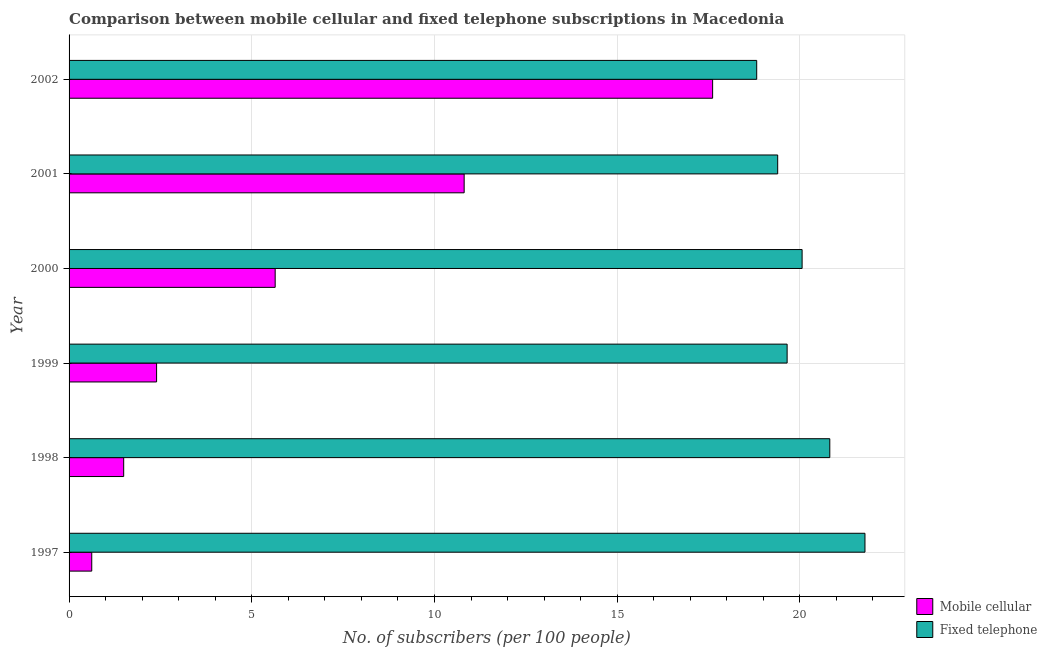How many different coloured bars are there?
Your answer should be very brief. 2. How many groups of bars are there?
Offer a terse response. 6. How many bars are there on the 1st tick from the top?
Offer a terse response. 2. How many bars are there on the 2nd tick from the bottom?
Offer a very short reply. 2. What is the label of the 3rd group of bars from the top?
Offer a very short reply. 2000. In how many cases, is the number of bars for a given year not equal to the number of legend labels?
Give a very brief answer. 0. What is the number of fixed telephone subscribers in 2001?
Make the answer very short. 19.39. Across all years, what is the maximum number of fixed telephone subscribers?
Provide a short and direct response. 21.78. Across all years, what is the minimum number of mobile cellular subscribers?
Provide a succinct answer. 0.62. In which year was the number of fixed telephone subscribers maximum?
Ensure brevity in your answer.  1997. In which year was the number of mobile cellular subscribers minimum?
Give a very brief answer. 1997. What is the total number of mobile cellular subscribers in the graph?
Your response must be concise. 38.57. What is the difference between the number of mobile cellular subscribers in 2000 and that in 2001?
Your answer should be very brief. -5.17. What is the difference between the number of fixed telephone subscribers in 1997 and the number of mobile cellular subscribers in 2000?
Ensure brevity in your answer.  16.14. What is the average number of fixed telephone subscribers per year?
Provide a short and direct response. 20.09. In the year 2001, what is the difference between the number of fixed telephone subscribers and number of mobile cellular subscribers?
Offer a terse response. 8.58. What is the ratio of the number of mobile cellular subscribers in 1997 to that in 1999?
Give a very brief answer. 0.26. Is the number of fixed telephone subscribers in 1997 less than that in 1999?
Give a very brief answer. No. Is the difference between the number of fixed telephone subscribers in 2001 and 2002 greater than the difference between the number of mobile cellular subscribers in 2001 and 2002?
Make the answer very short. Yes. What is the difference between the highest and the second highest number of mobile cellular subscribers?
Your response must be concise. 6.8. What is the difference between the highest and the lowest number of mobile cellular subscribers?
Your response must be concise. 16.99. Is the sum of the number of mobile cellular subscribers in 1997 and 2002 greater than the maximum number of fixed telephone subscribers across all years?
Provide a succinct answer. No. What does the 2nd bar from the top in 1997 represents?
Your response must be concise. Mobile cellular. What does the 2nd bar from the bottom in 2001 represents?
Keep it short and to the point. Fixed telephone. How many bars are there?
Your answer should be very brief. 12. Are all the bars in the graph horizontal?
Ensure brevity in your answer.  Yes. What is the difference between two consecutive major ticks on the X-axis?
Your answer should be very brief. 5. Are the values on the major ticks of X-axis written in scientific E-notation?
Your answer should be compact. No. Does the graph contain any zero values?
Your answer should be compact. No. How many legend labels are there?
Ensure brevity in your answer.  2. How are the legend labels stacked?
Your answer should be very brief. Vertical. What is the title of the graph?
Ensure brevity in your answer.  Comparison between mobile cellular and fixed telephone subscriptions in Macedonia. Does "constant 2005 US$" appear as one of the legend labels in the graph?
Provide a succinct answer. No. What is the label or title of the X-axis?
Your answer should be compact. No. of subscribers (per 100 people). What is the label or title of the Y-axis?
Ensure brevity in your answer.  Year. What is the No. of subscribers (per 100 people) of Mobile cellular in 1997?
Your answer should be very brief. 0.62. What is the No. of subscribers (per 100 people) in Fixed telephone in 1997?
Your response must be concise. 21.78. What is the No. of subscribers (per 100 people) of Mobile cellular in 1998?
Your answer should be compact. 1.49. What is the No. of subscribers (per 100 people) in Fixed telephone in 1998?
Make the answer very short. 20.82. What is the No. of subscribers (per 100 people) of Mobile cellular in 1999?
Your answer should be compact. 2.4. What is the No. of subscribers (per 100 people) in Fixed telephone in 1999?
Your response must be concise. 19.65. What is the No. of subscribers (per 100 people) in Mobile cellular in 2000?
Offer a terse response. 5.64. What is the No. of subscribers (per 100 people) in Fixed telephone in 2000?
Make the answer very short. 20.06. What is the No. of subscribers (per 100 people) in Mobile cellular in 2001?
Offer a very short reply. 10.81. What is the No. of subscribers (per 100 people) of Fixed telephone in 2001?
Keep it short and to the point. 19.39. What is the No. of subscribers (per 100 people) in Mobile cellular in 2002?
Provide a succinct answer. 17.61. What is the No. of subscribers (per 100 people) of Fixed telephone in 2002?
Your response must be concise. 18.82. Across all years, what is the maximum No. of subscribers (per 100 people) of Mobile cellular?
Offer a terse response. 17.61. Across all years, what is the maximum No. of subscribers (per 100 people) of Fixed telephone?
Your answer should be compact. 21.78. Across all years, what is the minimum No. of subscribers (per 100 people) of Mobile cellular?
Keep it short and to the point. 0.62. Across all years, what is the minimum No. of subscribers (per 100 people) in Fixed telephone?
Make the answer very short. 18.82. What is the total No. of subscribers (per 100 people) of Mobile cellular in the graph?
Provide a succinct answer. 38.57. What is the total No. of subscribers (per 100 people) of Fixed telephone in the graph?
Offer a very short reply. 120.52. What is the difference between the No. of subscribers (per 100 people) of Mobile cellular in 1997 and that in 1998?
Offer a terse response. -0.87. What is the difference between the No. of subscribers (per 100 people) in Fixed telephone in 1997 and that in 1998?
Provide a short and direct response. 0.96. What is the difference between the No. of subscribers (per 100 people) of Mobile cellular in 1997 and that in 1999?
Give a very brief answer. -1.77. What is the difference between the No. of subscribers (per 100 people) in Fixed telephone in 1997 and that in 1999?
Your answer should be compact. 2.13. What is the difference between the No. of subscribers (per 100 people) of Mobile cellular in 1997 and that in 2000?
Provide a succinct answer. -5.02. What is the difference between the No. of subscribers (per 100 people) in Fixed telephone in 1997 and that in 2000?
Keep it short and to the point. 1.72. What is the difference between the No. of subscribers (per 100 people) in Mobile cellular in 1997 and that in 2001?
Keep it short and to the point. -10.19. What is the difference between the No. of subscribers (per 100 people) of Fixed telephone in 1997 and that in 2001?
Give a very brief answer. 2.39. What is the difference between the No. of subscribers (per 100 people) of Mobile cellular in 1997 and that in 2002?
Your answer should be compact. -16.99. What is the difference between the No. of subscribers (per 100 people) of Fixed telephone in 1997 and that in 2002?
Your answer should be compact. 2.96. What is the difference between the No. of subscribers (per 100 people) of Mobile cellular in 1998 and that in 1999?
Offer a terse response. -0.9. What is the difference between the No. of subscribers (per 100 people) of Fixed telephone in 1998 and that in 1999?
Make the answer very short. 1.17. What is the difference between the No. of subscribers (per 100 people) in Mobile cellular in 1998 and that in 2000?
Provide a short and direct response. -4.15. What is the difference between the No. of subscribers (per 100 people) in Fixed telephone in 1998 and that in 2000?
Ensure brevity in your answer.  0.76. What is the difference between the No. of subscribers (per 100 people) of Mobile cellular in 1998 and that in 2001?
Offer a terse response. -9.32. What is the difference between the No. of subscribers (per 100 people) in Fixed telephone in 1998 and that in 2001?
Provide a succinct answer. 1.43. What is the difference between the No. of subscribers (per 100 people) in Mobile cellular in 1998 and that in 2002?
Your response must be concise. -16.12. What is the difference between the No. of subscribers (per 100 people) of Fixed telephone in 1998 and that in 2002?
Your answer should be compact. 2. What is the difference between the No. of subscribers (per 100 people) in Mobile cellular in 1999 and that in 2000?
Provide a succinct answer. -3.25. What is the difference between the No. of subscribers (per 100 people) in Fixed telephone in 1999 and that in 2000?
Ensure brevity in your answer.  -0.41. What is the difference between the No. of subscribers (per 100 people) of Mobile cellular in 1999 and that in 2001?
Give a very brief answer. -8.42. What is the difference between the No. of subscribers (per 100 people) of Fixed telephone in 1999 and that in 2001?
Your response must be concise. 0.26. What is the difference between the No. of subscribers (per 100 people) of Mobile cellular in 1999 and that in 2002?
Your answer should be compact. -15.22. What is the difference between the No. of subscribers (per 100 people) in Fixed telephone in 1999 and that in 2002?
Your answer should be very brief. 0.83. What is the difference between the No. of subscribers (per 100 people) of Mobile cellular in 2000 and that in 2001?
Offer a terse response. -5.17. What is the difference between the No. of subscribers (per 100 people) of Fixed telephone in 2000 and that in 2001?
Make the answer very short. 0.67. What is the difference between the No. of subscribers (per 100 people) in Mobile cellular in 2000 and that in 2002?
Ensure brevity in your answer.  -11.97. What is the difference between the No. of subscribers (per 100 people) in Fixed telephone in 2000 and that in 2002?
Provide a short and direct response. 1.24. What is the difference between the No. of subscribers (per 100 people) in Mobile cellular in 2001 and that in 2002?
Your answer should be compact. -6.8. What is the difference between the No. of subscribers (per 100 people) of Fixed telephone in 2001 and that in 2002?
Offer a terse response. 0.57. What is the difference between the No. of subscribers (per 100 people) of Mobile cellular in 1997 and the No. of subscribers (per 100 people) of Fixed telephone in 1998?
Ensure brevity in your answer.  -20.2. What is the difference between the No. of subscribers (per 100 people) in Mobile cellular in 1997 and the No. of subscribers (per 100 people) in Fixed telephone in 1999?
Ensure brevity in your answer.  -19.03. What is the difference between the No. of subscribers (per 100 people) of Mobile cellular in 1997 and the No. of subscribers (per 100 people) of Fixed telephone in 2000?
Keep it short and to the point. -19.44. What is the difference between the No. of subscribers (per 100 people) in Mobile cellular in 1997 and the No. of subscribers (per 100 people) in Fixed telephone in 2001?
Give a very brief answer. -18.77. What is the difference between the No. of subscribers (per 100 people) of Mobile cellular in 1997 and the No. of subscribers (per 100 people) of Fixed telephone in 2002?
Make the answer very short. -18.2. What is the difference between the No. of subscribers (per 100 people) in Mobile cellular in 1998 and the No. of subscribers (per 100 people) in Fixed telephone in 1999?
Ensure brevity in your answer.  -18.16. What is the difference between the No. of subscribers (per 100 people) of Mobile cellular in 1998 and the No. of subscribers (per 100 people) of Fixed telephone in 2000?
Keep it short and to the point. -18.57. What is the difference between the No. of subscribers (per 100 people) in Mobile cellular in 1998 and the No. of subscribers (per 100 people) in Fixed telephone in 2001?
Your answer should be compact. -17.9. What is the difference between the No. of subscribers (per 100 people) of Mobile cellular in 1998 and the No. of subscribers (per 100 people) of Fixed telephone in 2002?
Your answer should be compact. -17.32. What is the difference between the No. of subscribers (per 100 people) in Mobile cellular in 1999 and the No. of subscribers (per 100 people) in Fixed telephone in 2000?
Provide a short and direct response. -17.67. What is the difference between the No. of subscribers (per 100 people) in Mobile cellular in 1999 and the No. of subscribers (per 100 people) in Fixed telephone in 2001?
Your response must be concise. -17. What is the difference between the No. of subscribers (per 100 people) of Mobile cellular in 1999 and the No. of subscribers (per 100 people) of Fixed telephone in 2002?
Ensure brevity in your answer.  -16.42. What is the difference between the No. of subscribers (per 100 people) in Mobile cellular in 2000 and the No. of subscribers (per 100 people) in Fixed telephone in 2001?
Your answer should be compact. -13.75. What is the difference between the No. of subscribers (per 100 people) of Mobile cellular in 2000 and the No. of subscribers (per 100 people) of Fixed telephone in 2002?
Make the answer very short. -13.18. What is the difference between the No. of subscribers (per 100 people) of Mobile cellular in 2001 and the No. of subscribers (per 100 people) of Fixed telephone in 2002?
Offer a very short reply. -8.01. What is the average No. of subscribers (per 100 people) of Mobile cellular per year?
Provide a short and direct response. 6.43. What is the average No. of subscribers (per 100 people) of Fixed telephone per year?
Make the answer very short. 20.09. In the year 1997, what is the difference between the No. of subscribers (per 100 people) of Mobile cellular and No. of subscribers (per 100 people) of Fixed telephone?
Offer a very short reply. -21.16. In the year 1998, what is the difference between the No. of subscribers (per 100 people) of Mobile cellular and No. of subscribers (per 100 people) of Fixed telephone?
Ensure brevity in your answer.  -19.32. In the year 1999, what is the difference between the No. of subscribers (per 100 people) of Mobile cellular and No. of subscribers (per 100 people) of Fixed telephone?
Your response must be concise. -17.25. In the year 2000, what is the difference between the No. of subscribers (per 100 people) of Mobile cellular and No. of subscribers (per 100 people) of Fixed telephone?
Provide a succinct answer. -14.42. In the year 2001, what is the difference between the No. of subscribers (per 100 people) in Mobile cellular and No. of subscribers (per 100 people) in Fixed telephone?
Your answer should be compact. -8.58. In the year 2002, what is the difference between the No. of subscribers (per 100 people) in Mobile cellular and No. of subscribers (per 100 people) in Fixed telephone?
Offer a very short reply. -1.21. What is the ratio of the No. of subscribers (per 100 people) of Mobile cellular in 1997 to that in 1998?
Ensure brevity in your answer.  0.42. What is the ratio of the No. of subscribers (per 100 people) of Fixed telephone in 1997 to that in 1998?
Provide a short and direct response. 1.05. What is the ratio of the No. of subscribers (per 100 people) of Mobile cellular in 1997 to that in 1999?
Make the answer very short. 0.26. What is the ratio of the No. of subscribers (per 100 people) in Fixed telephone in 1997 to that in 1999?
Provide a succinct answer. 1.11. What is the ratio of the No. of subscribers (per 100 people) of Mobile cellular in 1997 to that in 2000?
Keep it short and to the point. 0.11. What is the ratio of the No. of subscribers (per 100 people) of Fixed telephone in 1997 to that in 2000?
Your answer should be compact. 1.09. What is the ratio of the No. of subscribers (per 100 people) of Mobile cellular in 1997 to that in 2001?
Give a very brief answer. 0.06. What is the ratio of the No. of subscribers (per 100 people) in Fixed telephone in 1997 to that in 2001?
Your answer should be compact. 1.12. What is the ratio of the No. of subscribers (per 100 people) of Mobile cellular in 1997 to that in 2002?
Offer a very short reply. 0.04. What is the ratio of the No. of subscribers (per 100 people) of Fixed telephone in 1997 to that in 2002?
Offer a very short reply. 1.16. What is the ratio of the No. of subscribers (per 100 people) of Mobile cellular in 1998 to that in 1999?
Make the answer very short. 0.62. What is the ratio of the No. of subscribers (per 100 people) of Fixed telephone in 1998 to that in 1999?
Provide a short and direct response. 1.06. What is the ratio of the No. of subscribers (per 100 people) of Mobile cellular in 1998 to that in 2000?
Make the answer very short. 0.27. What is the ratio of the No. of subscribers (per 100 people) in Fixed telephone in 1998 to that in 2000?
Offer a very short reply. 1.04. What is the ratio of the No. of subscribers (per 100 people) of Mobile cellular in 1998 to that in 2001?
Your response must be concise. 0.14. What is the ratio of the No. of subscribers (per 100 people) in Fixed telephone in 1998 to that in 2001?
Provide a succinct answer. 1.07. What is the ratio of the No. of subscribers (per 100 people) of Mobile cellular in 1998 to that in 2002?
Your response must be concise. 0.08. What is the ratio of the No. of subscribers (per 100 people) of Fixed telephone in 1998 to that in 2002?
Provide a succinct answer. 1.11. What is the ratio of the No. of subscribers (per 100 people) of Mobile cellular in 1999 to that in 2000?
Your answer should be very brief. 0.42. What is the ratio of the No. of subscribers (per 100 people) in Fixed telephone in 1999 to that in 2000?
Your response must be concise. 0.98. What is the ratio of the No. of subscribers (per 100 people) in Mobile cellular in 1999 to that in 2001?
Make the answer very short. 0.22. What is the ratio of the No. of subscribers (per 100 people) of Fixed telephone in 1999 to that in 2001?
Give a very brief answer. 1.01. What is the ratio of the No. of subscribers (per 100 people) in Mobile cellular in 1999 to that in 2002?
Offer a terse response. 0.14. What is the ratio of the No. of subscribers (per 100 people) in Fixed telephone in 1999 to that in 2002?
Offer a very short reply. 1.04. What is the ratio of the No. of subscribers (per 100 people) of Mobile cellular in 2000 to that in 2001?
Offer a terse response. 0.52. What is the ratio of the No. of subscribers (per 100 people) in Fixed telephone in 2000 to that in 2001?
Offer a terse response. 1.03. What is the ratio of the No. of subscribers (per 100 people) in Mobile cellular in 2000 to that in 2002?
Offer a very short reply. 0.32. What is the ratio of the No. of subscribers (per 100 people) in Fixed telephone in 2000 to that in 2002?
Give a very brief answer. 1.07. What is the ratio of the No. of subscribers (per 100 people) of Mobile cellular in 2001 to that in 2002?
Offer a very short reply. 0.61. What is the ratio of the No. of subscribers (per 100 people) of Fixed telephone in 2001 to that in 2002?
Ensure brevity in your answer.  1.03. What is the difference between the highest and the second highest No. of subscribers (per 100 people) in Mobile cellular?
Offer a terse response. 6.8. What is the difference between the highest and the second highest No. of subscribers (per 100 people) of Fixed telephone?
Provide a succinct answer. 0.96. What is the difference between the highest and the lowest No. of subscribers (per 100 people) in Mobile cellular?
Your answer should be compact. 16.99. What is the difference between the highest and the lowest No. of subscribers (per 100 people) in Fixed telephone?
Provide a short and direct response. 2.96. 